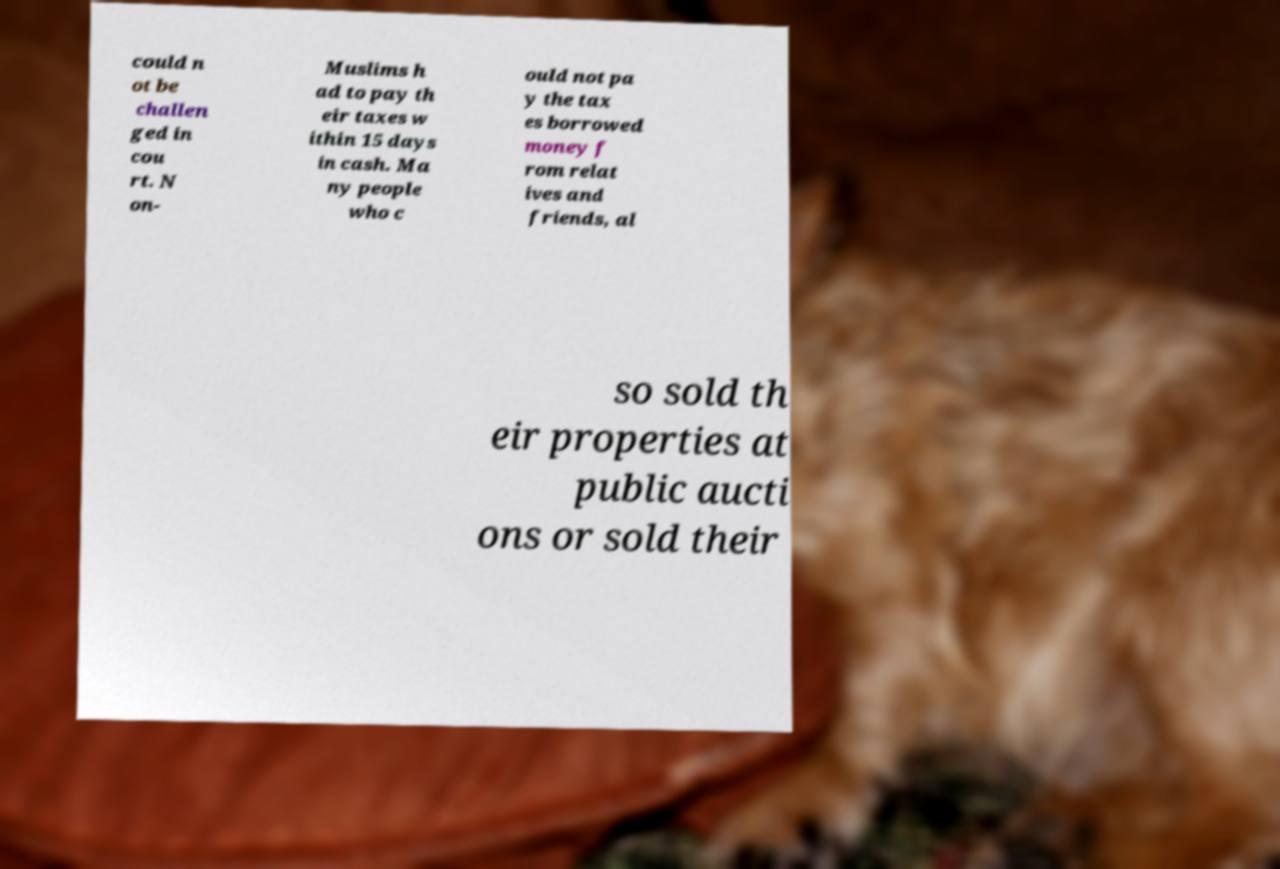Can you accurately transcribe the text from the provided image for me? could n ot be challen ged in cou rt. N on- Muslims h ad to pay th eir taxes w ithin 15 days in cash. Ma ny people who c ould not pa y the tax es borrowed money f rom relat ives and friends, al so sold th eir properties at public aucti ons or sold their 